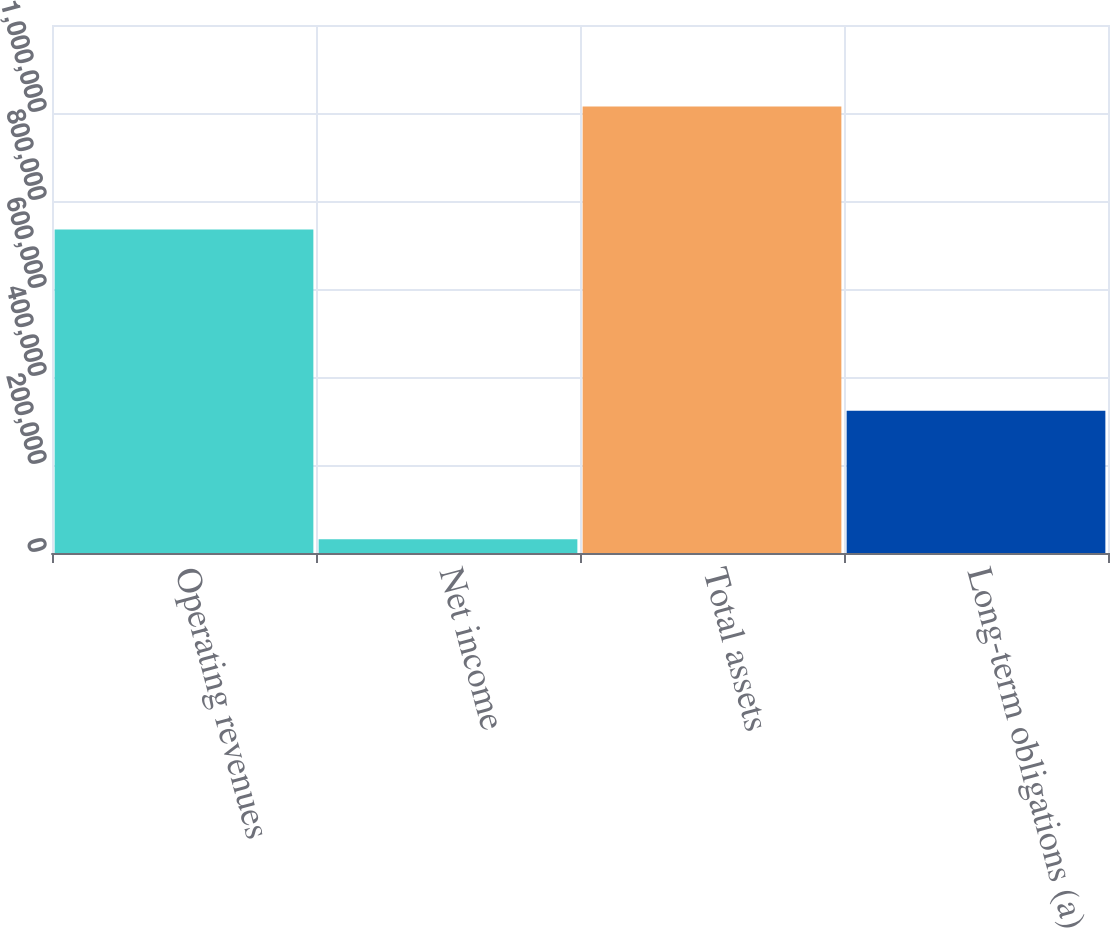Convert chart to OTSL. <chart><loc_0><loc_0><loc_500><loc_500><bar_chart><fcel>Operating revenues<fcel>Net income<fcel>Total assets<fcel>Long-term obligations (a)<nl><fcel>735192<fcel>31030<fcel>1.01492e+06<fcel>323280<nl></chart> 